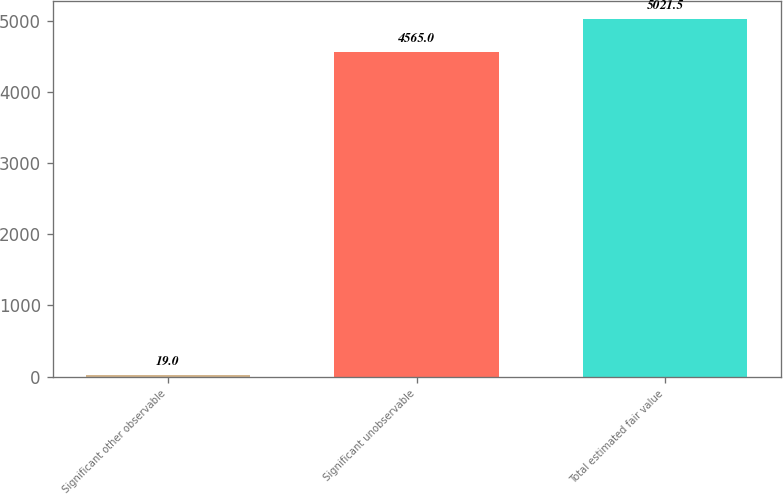Convert chart to OTSL. <chart><loc_0><loc_0><loc_500><loc_500><bar_chart><fcel>Significant other observable<fcel>Significant unobservable<fcel>Total estimated fair value<nl><fcel>19<fcel>4565<fcel>5021.5<nl></chart> 